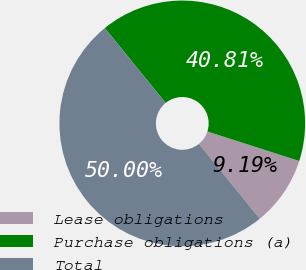Convert chart. <chart><loc_0><loc_0><loc_500><loc_500><pie_chart><fcel>Lease obligations<fcel>Purchase obligations (a)<fcel>Total<nl><fcel>9.19%<fcel>40.81%<fcel>50.0%<nl></chart> 